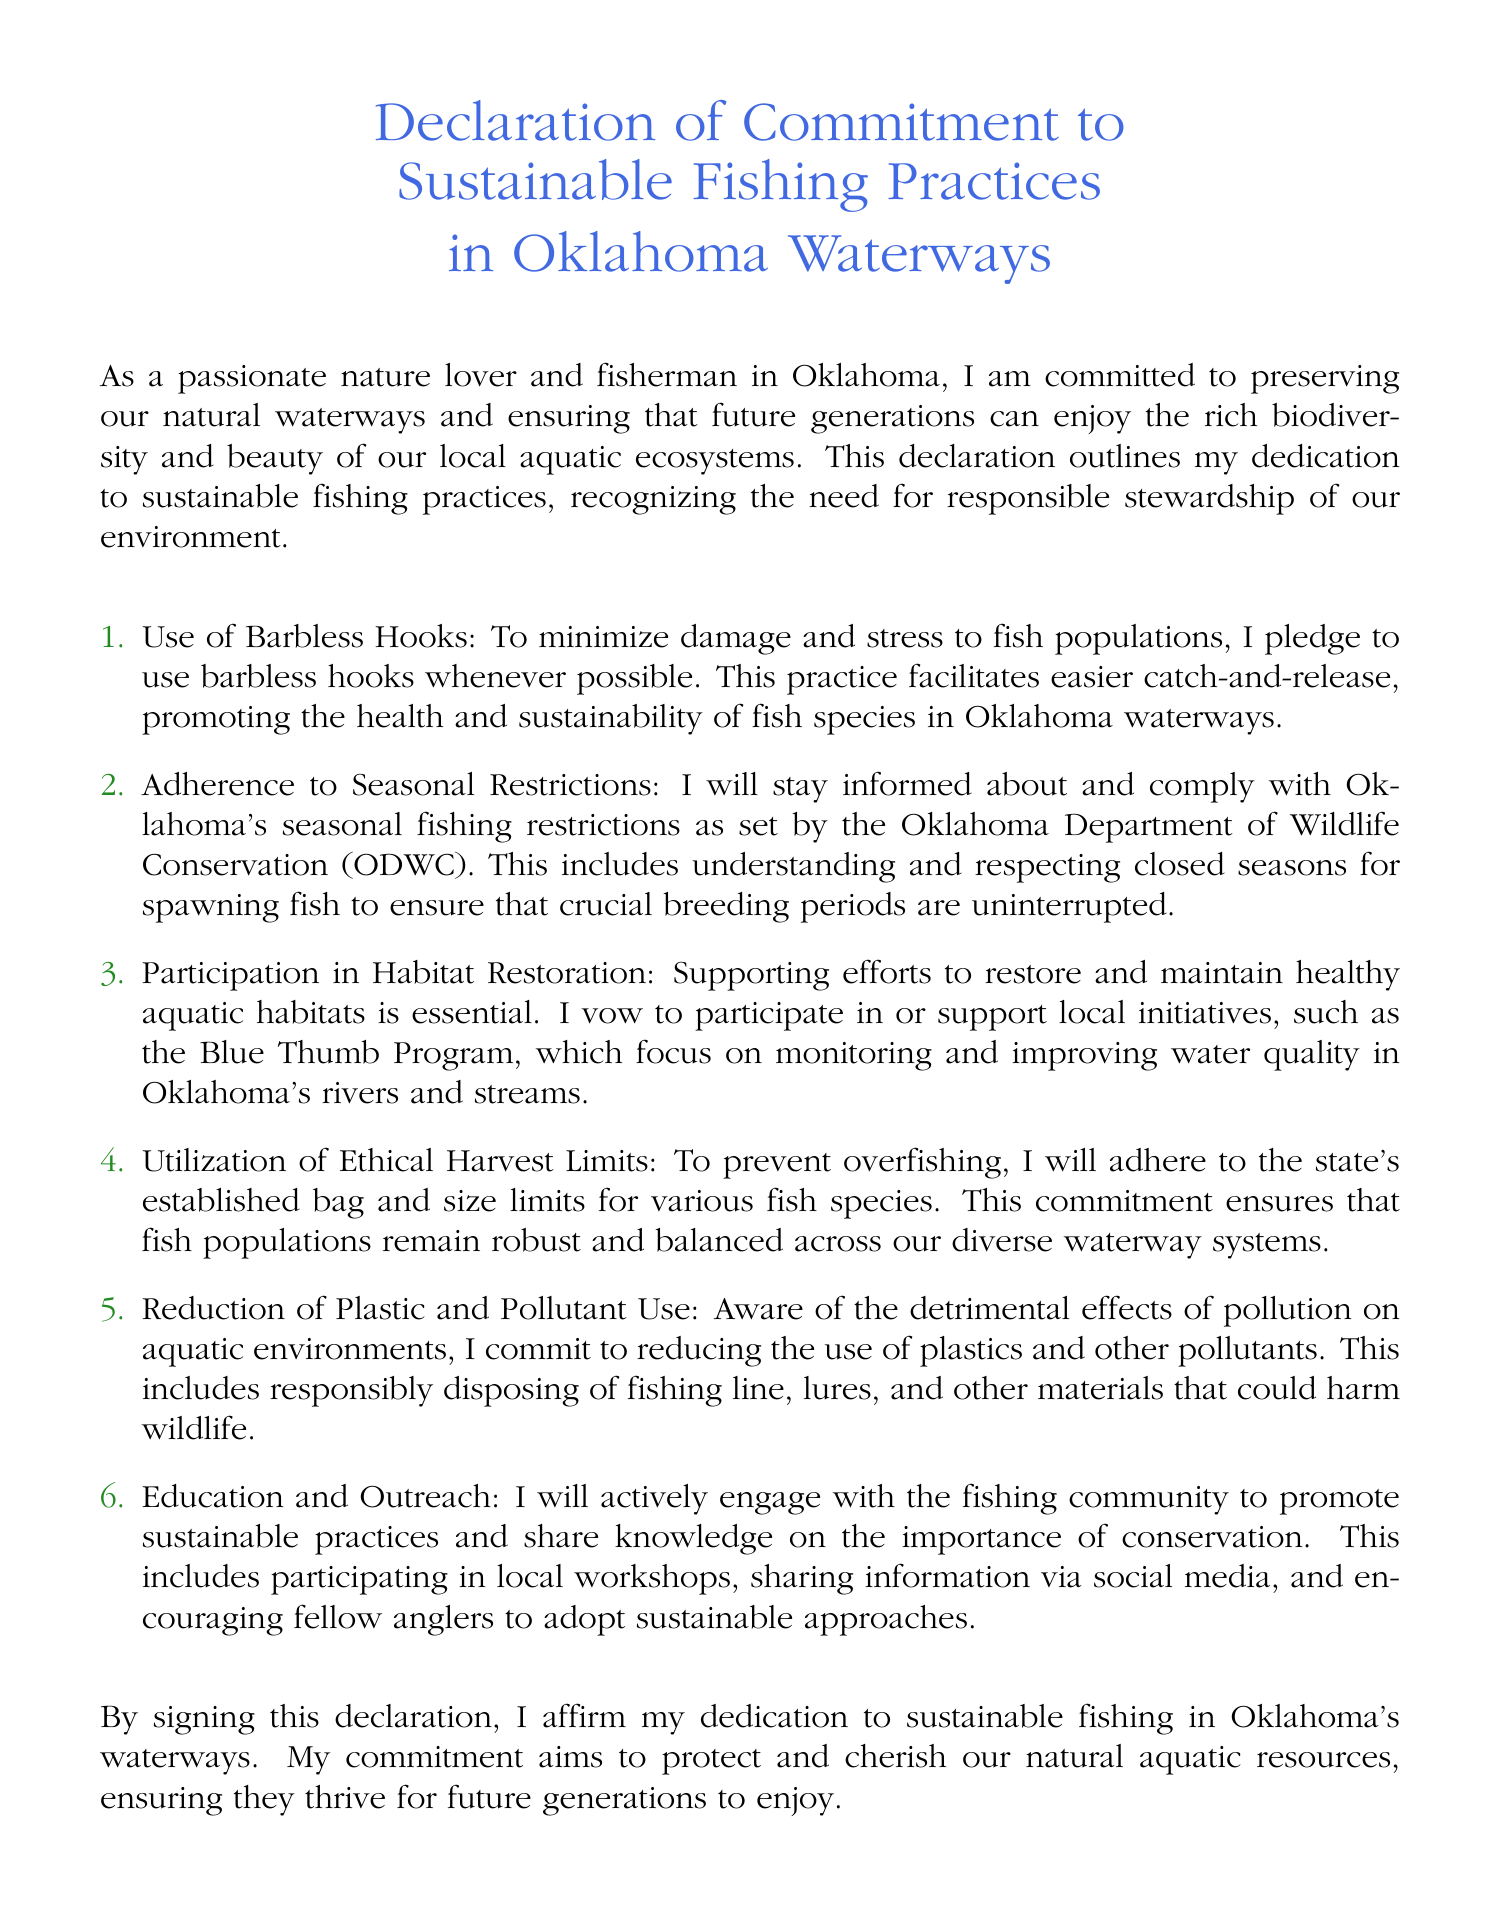What is the main commitment outlined in the document? The document expresses a commitment to sustainable fishing practices in Oklahoma waterways.
Answer: sustainable fishing practices What is the first method mentioned in the commitment? The first method discussed is the use of barbless hooks to minimize damage to fish populations.
Answer: Use of Barbless Hooks Which organization’s seasonal restrictions does the commitment emphasize adherence to? The commitment emphasizes compliance with restrictions set by the Oklahoma Department of Wildlife Conservation.
Answer: Oklahoma Department of Wildlife Conservation What program does the document mention for habitat restoration? The document mentions the Blue Thumb Program as a local initiative focused on monitoring and improving water quality.
Answer: Blue Thumb Program What is stated as a reason for adherence to bag and size limits? Adherence to bag and size limits helps to prevent overfishing and ensures robust fish populations.
Answer: prevent overfishing What environmental issue is addressed in the commitment related to pollutants? The commitment addresses the reduction of plastic and pollutants to protect aquatic environments.
Answer: reduction of plastic and pollutants How does the commitment suggest promoting sustainable practices in the fishing community? The commitment suggests engaging with the fishing community through workshops and social media for education and outreach.
Answer: education and outreach What is the concluding action expressed in the declaration? The declaration concludes with the signing as an affirmation of dedication to sustainable fishing.
Answer: signing the declaration 